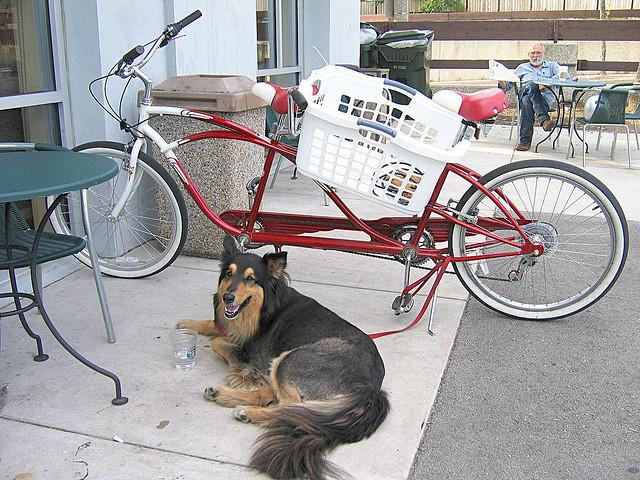What is the bike being used to transport?

Choices:
A) mail
B) hamper
C) dogs
D) water hamper 